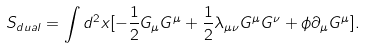Convert formula to latex. <formula><loc_0><loc_0><loc_500><loc_500>S _ { d u a l } = \int d ^ { 2 } x [ - \frac { 1 } { 2 } G _ { \mu } G ^ { \mu } + \frac { 1 } { 2 } \lambda _ { \mu \nu } G ^ { \mu } G ^ { \nu } + \phi \partial _ { \mu } G ^ { \mu } ] .</formula> 